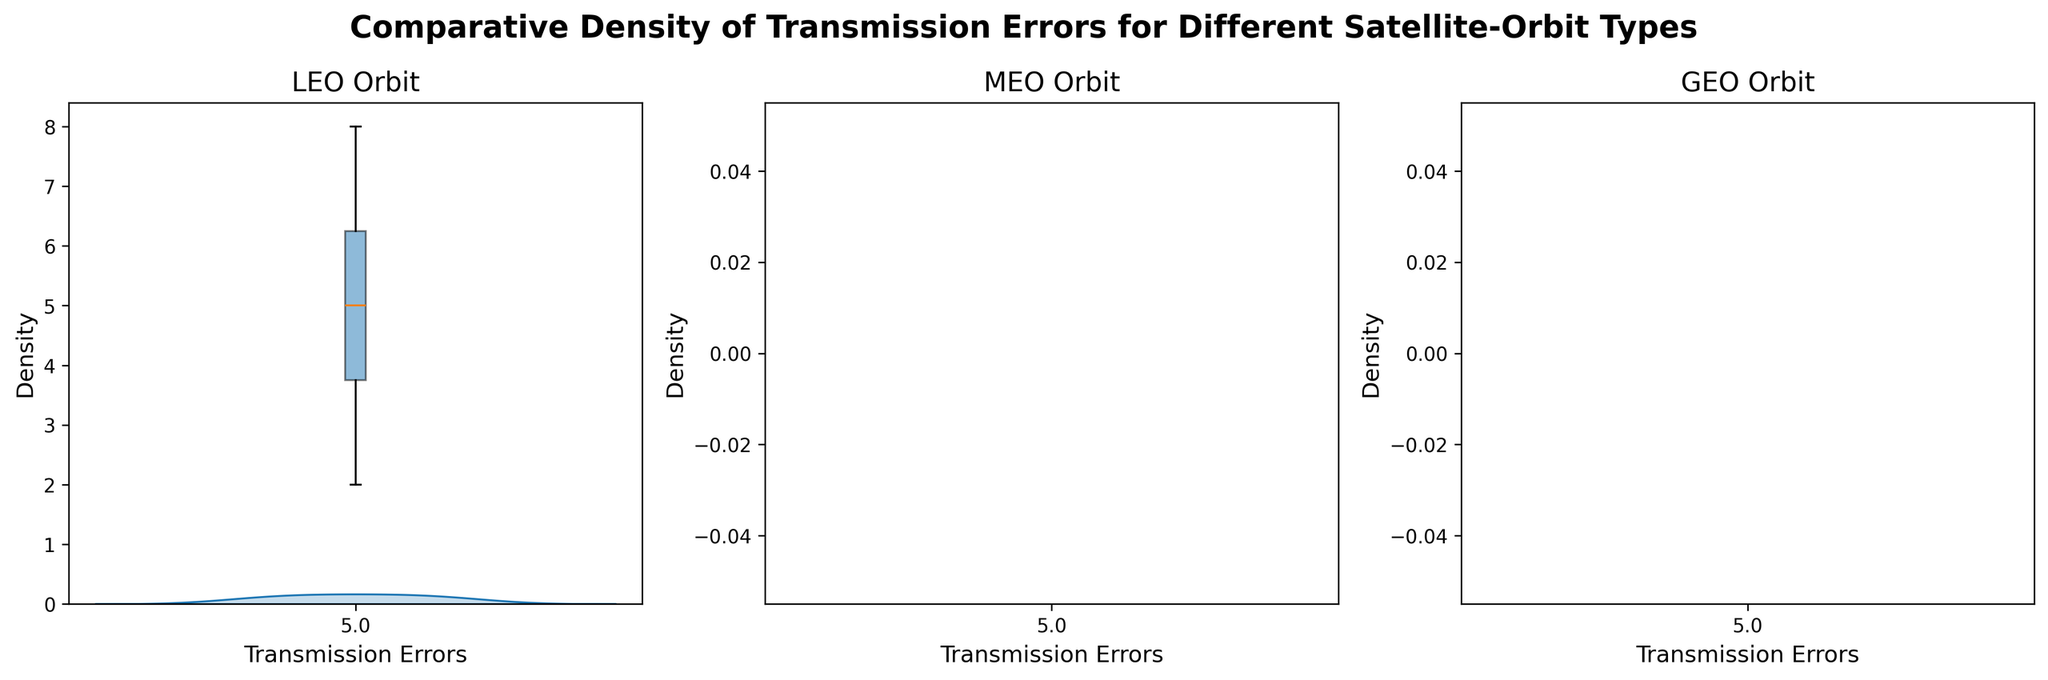What is the title of the figure? The title of the figure is usually displayed at the top of the plot, summarizing the overall objective or the data being visualized.
Answer: Comparative Density of Transmission Errors for Different Satellite-Orbit Types Which color represents the LEO orbit? The color representing the LEO orbit can be identified from the density plots and it is specified in the code as well.
Answer: Blue How many subplots are there in the figure? The number of subplots can be counted based on the individual density plots shown for different orbit types.
Answer: 3 Which orbit type has the highest density peak? By examining the density curves, the highest peak indicates the orbit type with the greatest density of transmission errors.
Answer: GEO What range of transmission errors is shown for MEO orbit? The range can be determined by observing the x-axis limits of the density plot for the MEO orbit.
Answer: 8 to 12 Which orbit type has the widest box in its boxplot? The width of the boxplot reflects the spread of transmission error data for each orbit type. The orbit with the widest box has the greatest variability.
Answer: MEO What is the median transmission error value for the GEO orbit as seen in the boxplot? The median value is indicated by the line inside the box of the boxplot for the GEO orbit.
Answer: 15 Among the LEO, MEO, and GEO orbits, which has the lowest transmission error value observed? The lowest value can be identified by examining the minimum limits of the density plots and boxplots for each orbit type.
Answer: LEO How does the density of transmission errors in MEO orbit compare to GEO orbit? Comparing the density curves of both MEO and GEO orbits will show which has a higher or lower density, interpreted from the height of the peaks.
Answer: MEO has lower density peaks compared to GEO Which orbit type shows the smallest variability in transmission errors? The orbit type with the smallest box in the boxplot indicates the least variability or spread in transmission errors.
Answer: GEO 